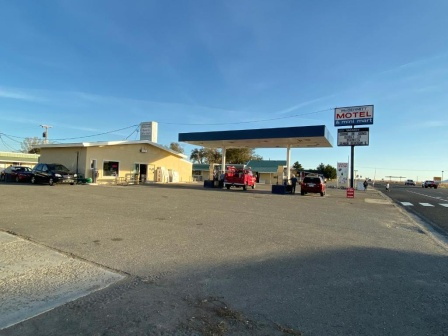What do you think is going on in this snapshot?
 The image captures a scene at a gas station and motel under a clear blue sky. The gas station, with its distinctive blue roof, is bustling with activity. A red truck is parked at the gas pumps, possibly refueling for a long journey ahead. Two other cars are parked in front of the gas station, perhaps belonging to customers inside.

Adjacent to the gas station is a single-story motel. Its white sign with red lettering that reads "MOTEL" stands out, welcoming travelers for a restful stay. The power lines running in the background add a touch of urban infrastructure to this otherwise serene setting. The entire scene is a snapshot of a typical day on the road, with vehicles coming and going, and the motel offering a respite for weary travelers. 